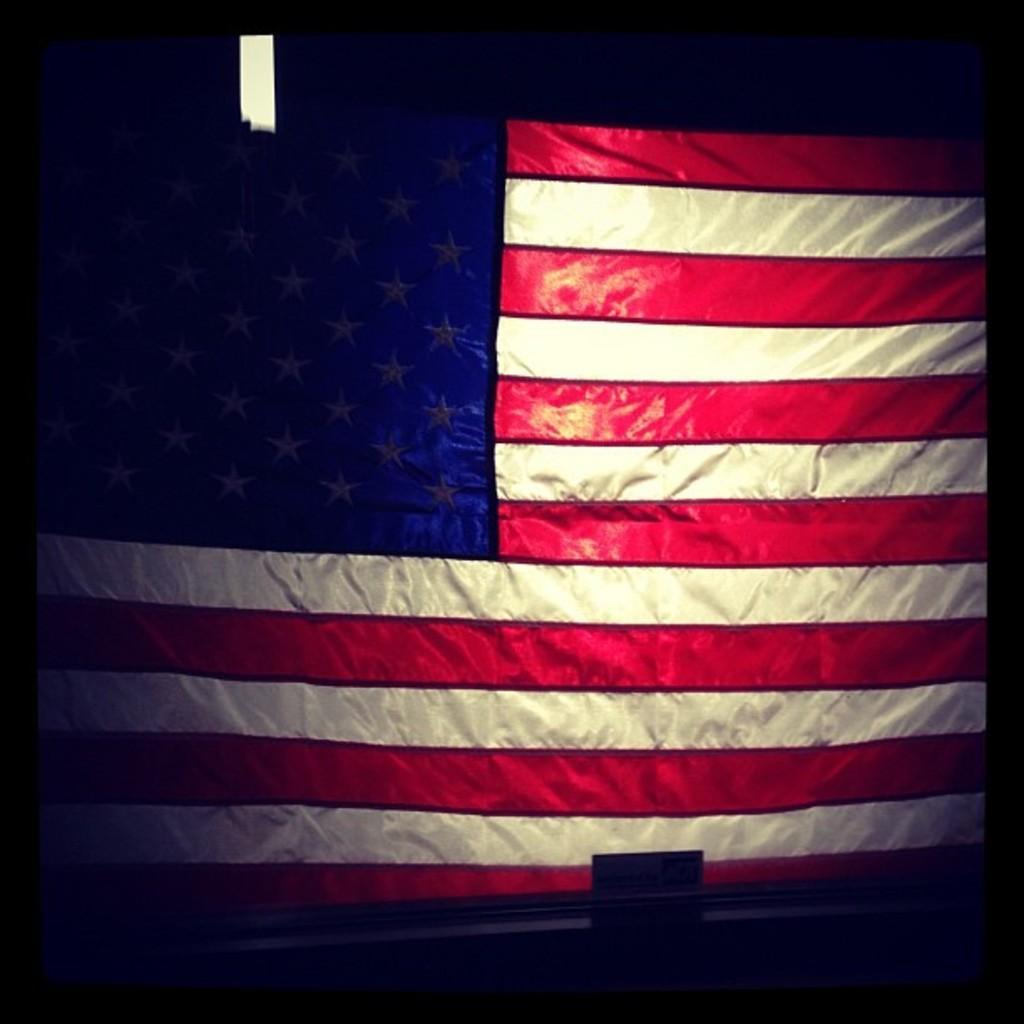Can you describe this image briefly? In this image I can see flag of the USA. I can also see this image is little bit in dark. 